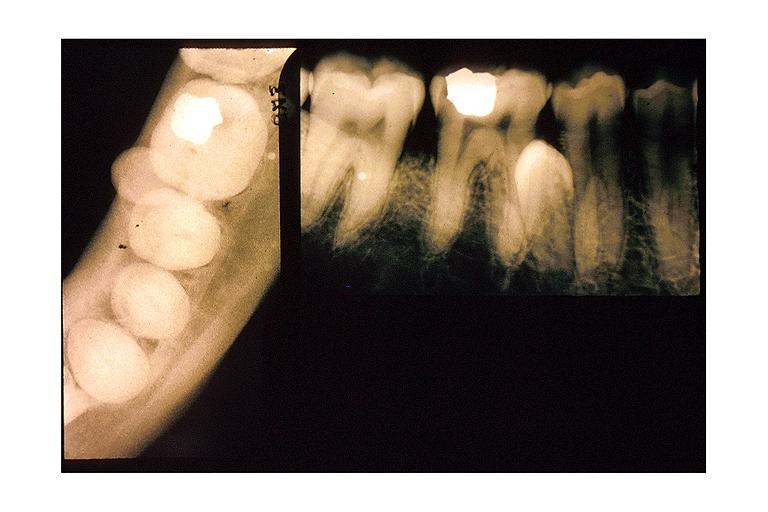what is present?
Answer the question using a single word or phrase. Oral 